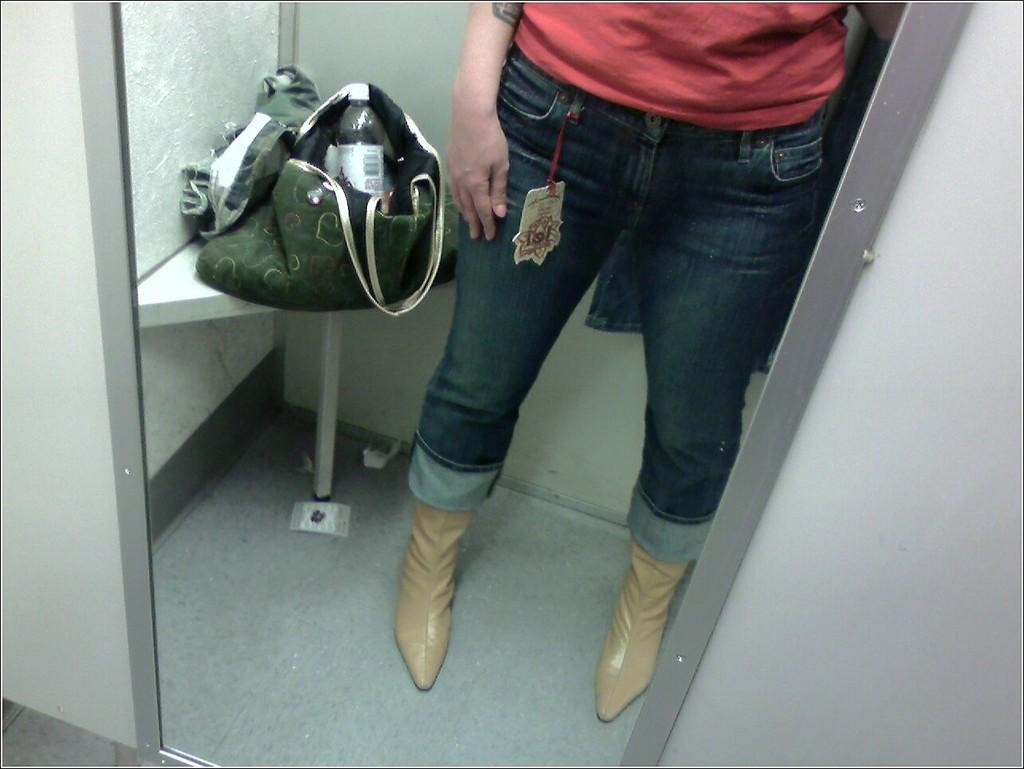In one or two sentences, can you explain what this image depicts? In the image we can see legs of a person. Beside them there is a bag and water bottle is in bag. 